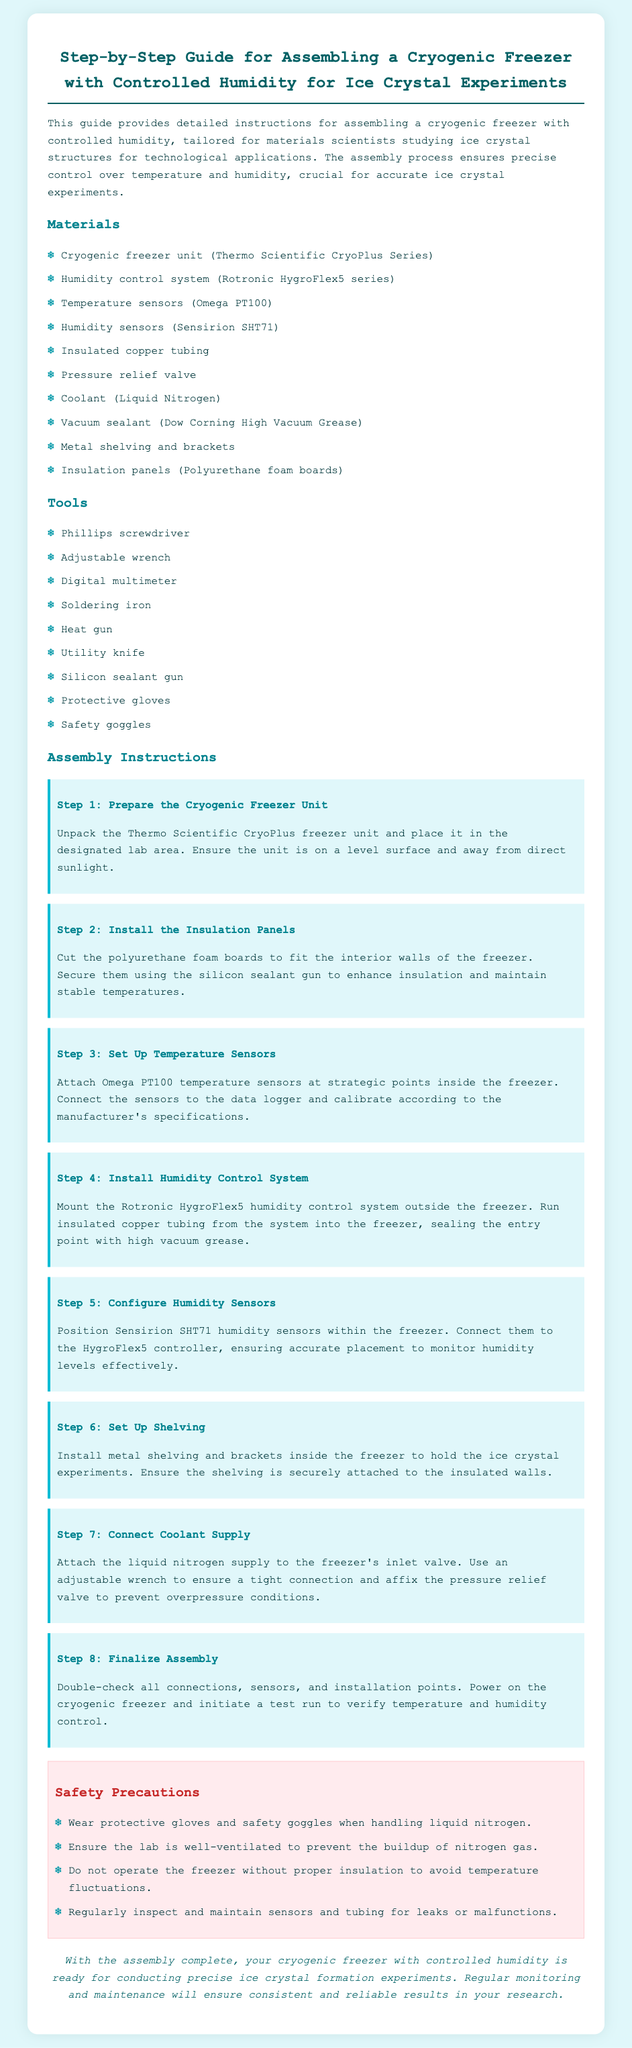What is the brand of the cryogenic freezer unit? The document specifies the cryogenic freezer unit as the Thermo Scientific CryoPlus Series.
Answer: Thermo Scientific CryoPlus Series What type of humidity control system is mentioned? The document refers to the humidity control system as the Rotronic HygroFlex5 series.
Answer: Rotronic HygroFlex5 series How many steps are included in the assembly instructions? The document outlines a total of 8 distinct steps for assembly.
Answer: 8 What material is used for the insulation panels? The insulation panels are made of polyurethane foam boards as per the instructions.
Answer: Polyurethane foam boards What should be worn when handling liquid nitrogen? The safety precautions instruct to wear protective gloves and safety goggles.
Answer: Protective gloves and safety goggles What type of temperature sensors should be installed? The document suggests using Omega PT100 temperature sensors for installation.
Answer: Omega PT100 What is the purpose of the pressure relief valve? The pressure relief valve is affixed to prevent overpressure conditions in the system.
Answer: Prevent overpressure conditions What is the final action to be taken during assembly? The last step includes powering on the cryogenic freezer and initiating a test run.
Answer: Power on the cryogenic freezer and initiate a test run 